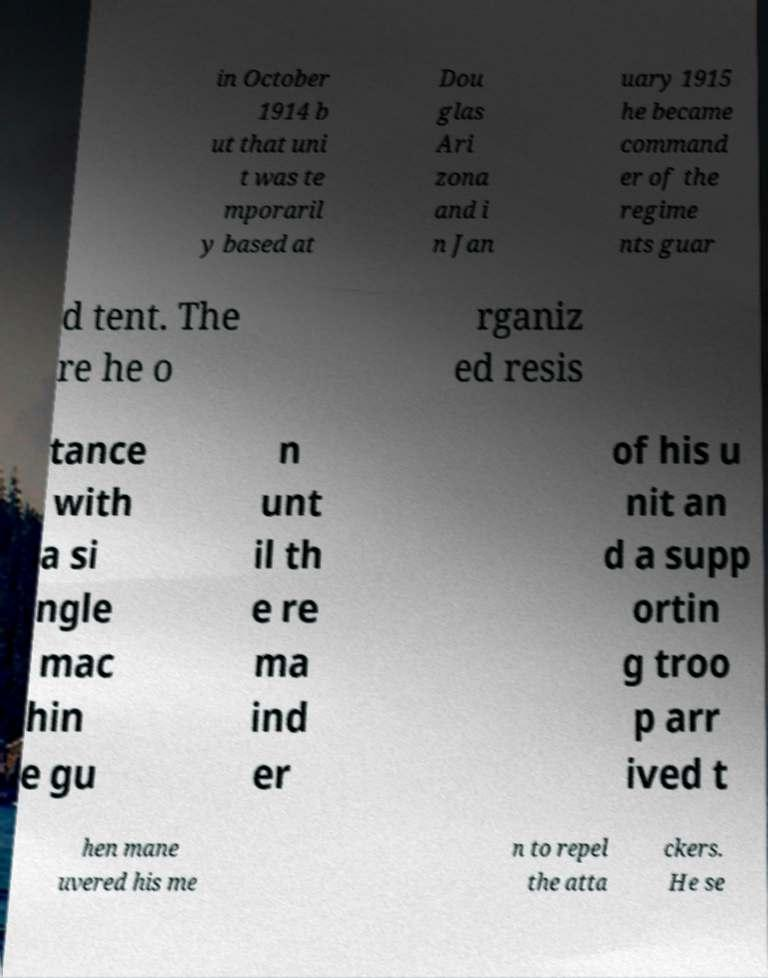Could you extract and type out the text from this image? in October 1914 b ut that uni t was te mporaril y based at Dou glas Ari zona and i n Jan uary 1915 he became command er of the regime nts guar d tent. The re he o rganiz ed resis tance with a si ngle mac hin e gu n unt il th e re ma ind er of his u nit an d a supp ortin g troo p arr ived t hen mane uvered his me n to repel the atta ckers. He se 